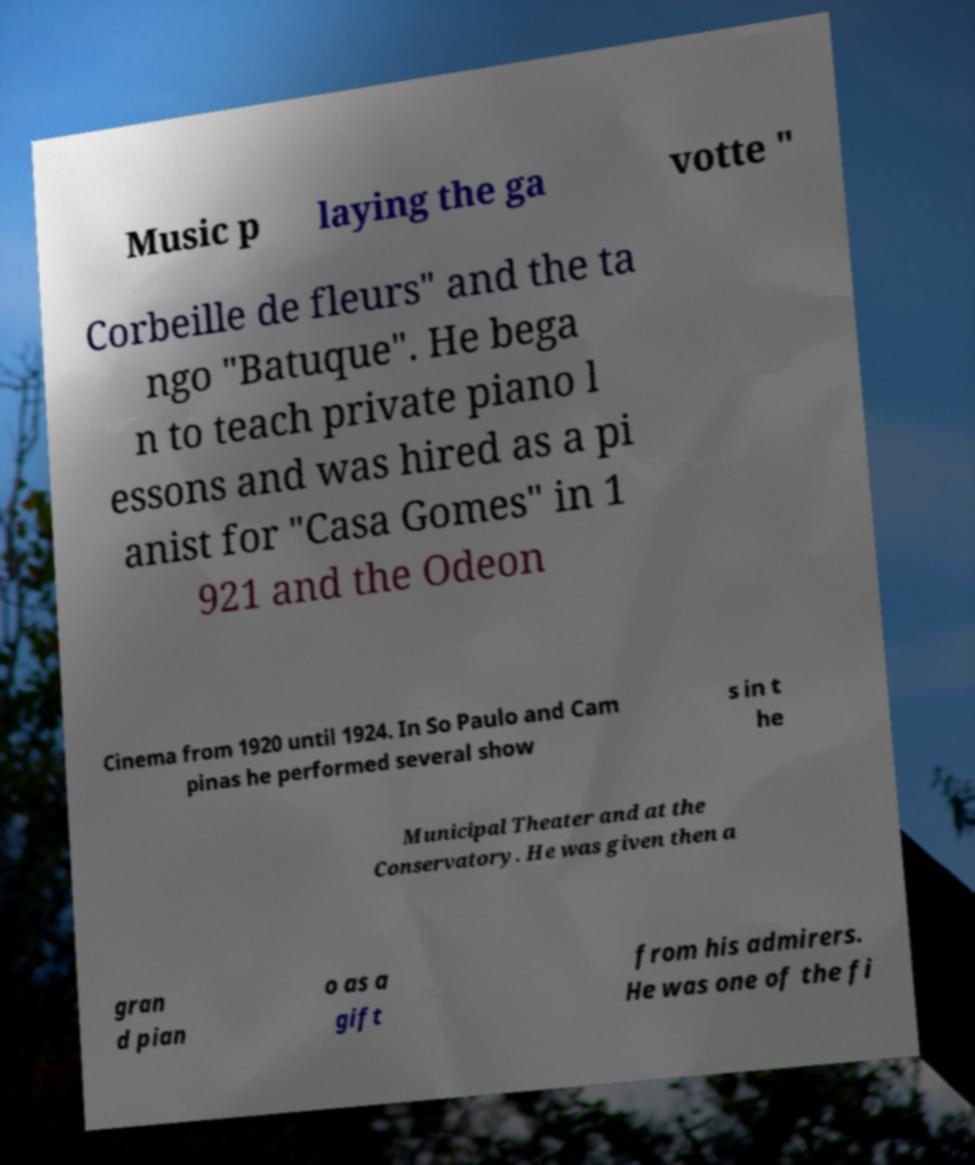Could you assist in decoding the text presented in this image and type it out clearly? Music p laying the ga votte " Corbeille de fleurs" and the ta ngo "Batuque". He bega n to teach private piano l essons and was hired as a pi anist for "Casa Gomes" in 1 921 and the Odeon Cinema from 1920 until 1924. In So Paulo and Cam pinas he performed several show s in t he Municipal Theater and at the Conservatory. He was given then a gran d pian o as a gift from his admirers. He was one of the fi 